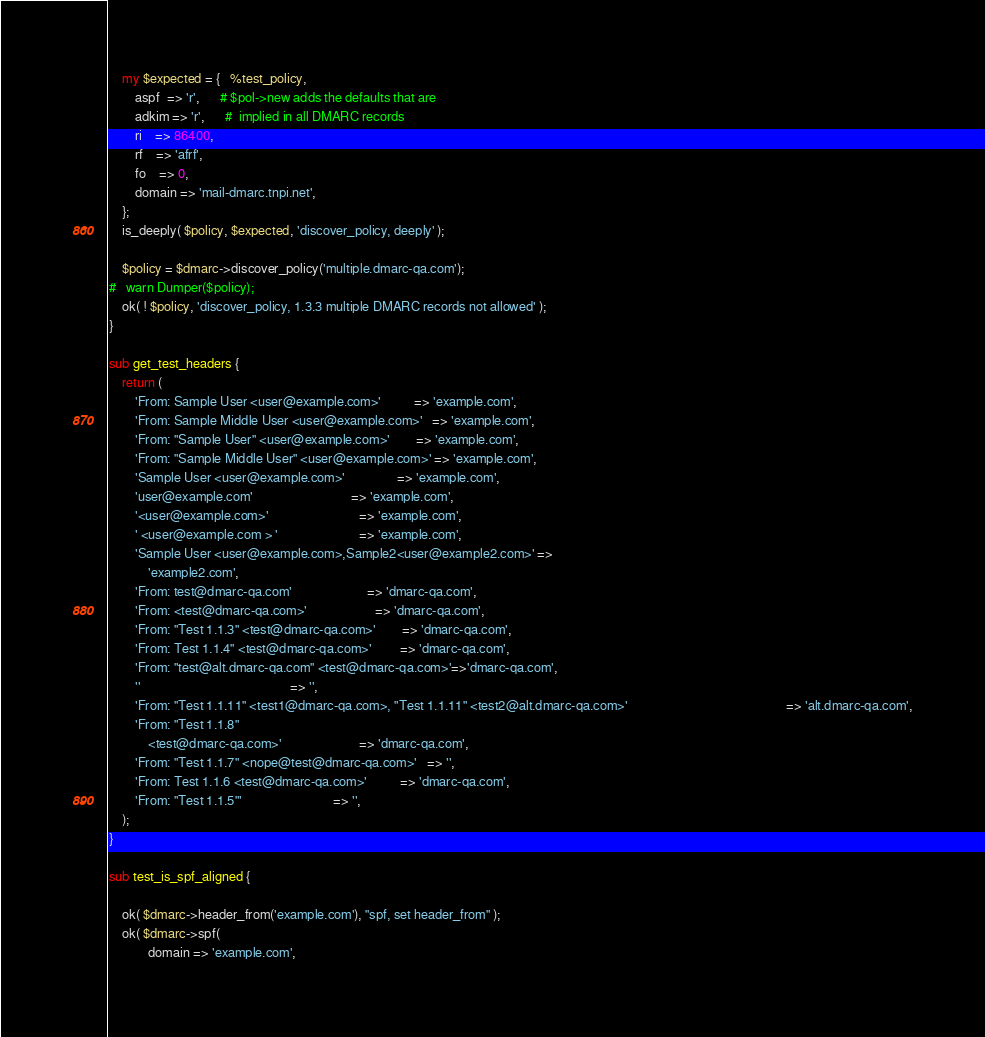<code> <loc_0><loc_0><loc_500><loc_500><_Perl_>    my $expected = {   %test_policy,
        aspf  => 'r',      # $pol->new adds the defaults that are
        adkim => 'r',      #  implied in all DMARC records
        ri    => 86400,
        rf    => 'afrf',
        fo    => 0,
        domain => 'mail-dmarc.tnpi.net',
    };
    is_deeply( $policy, $expected, 'discover_policy, deeply' );

    $policy = $dmarc->discover_policy('multiple.dmarc-qa.com');
#   warn Dumper($policy);
    ok( ! $policy, 'discover_policy, 1.3.3 multiple DMARC records not allowed' );
}

sub get_test_headers {
    return (
        'From: Sample User <user@example.com>'          => 'example.com',
        'From: Sample Middle User <user@example.com>'   => 'example.com',
        'From: "Sample User" <user@example.com>'        => 'example.com',
        'From: "Sample Middle User" <user@example.com>' => 'example.com',
        'Sample User <user@example.com>'                => 'example.com',
        'user@example.com'                              => 'example.com',
        '<user@example.com>'                            => 'example.com',
        ' <user@example.com > '                         => 'example.com',
        'Sample User <user@example.com>,Sample2<user@example2.com>' =>
            'example2.com',
        'From: test@dmarc-qa.com'                       => 'dmarc-qa.com',
        'From: <test@dmarc-qa.com>'                     => 'dmarc-qa.com',
        'From: "Test 1.1.3" <test@dmarc-qa.com>'        => 'dmarc-qa.com',
        'From: Test 1.1.4" <test@dmarc-qa.com>'         => 'dmarc-qa.com',
        'From: "test@alt.dmarc-qa.com" <test@dmarc-qa.com>'=>'dmarc-qa.com',
        ''                                              => '',
        'From: "Test 1.1.11" <test1@dmarc-qa.com>, "Test 1.1.11" <test2@alt.dmarc-qa.com>'                                                 => 'alt.dmarc-qa.com',
        'From: "Test 1.1.8"
            <test@dmarc-qa.com>'                        => 'dmarc-qa.com',
        'From: "Test 1.1.7" <nope@test@dmarc-qa.com>'   => '',
        'From: Test 1.1.6 <test@dmarc-qa.com>'          => 'dmarc-qa.com',
        'From: "Test 1.1.5"'                            => '',
    );
}

sub test_is_spf_aligned {

    ok( $dmarc->header_from('example.com'), "spf, set header_from" );
    ok( $dmarc->spf(
            domain => 'example.com',</code> 